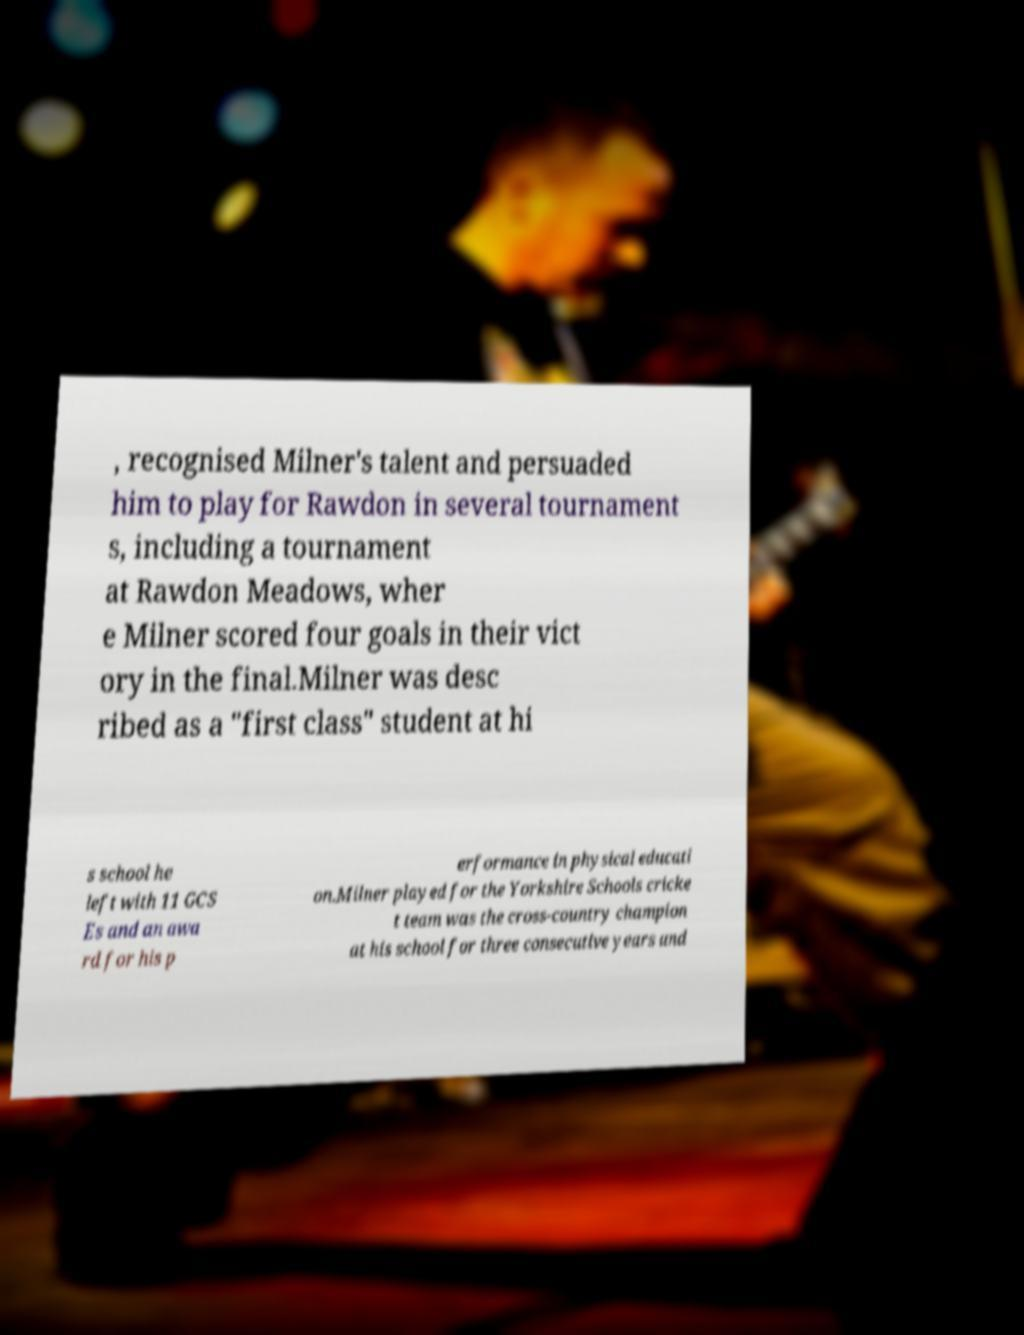Please read and relay the text visible in this image. What does it say? , recognised Milner's talent and persuaded him to play for Rawdon in several tournament s, including a tournament at Rawdon Meadows, wher e Milner scored four goals in their vict ory in the final.Milner was desc ribed as a "first class" student at hi s school he left with 11 GCS Es and an awa rd for his p erformance in physical educati on.Milner played for the Yorkshire Schools cricke t team was the cross-country champion at his school for three consecutive years and 